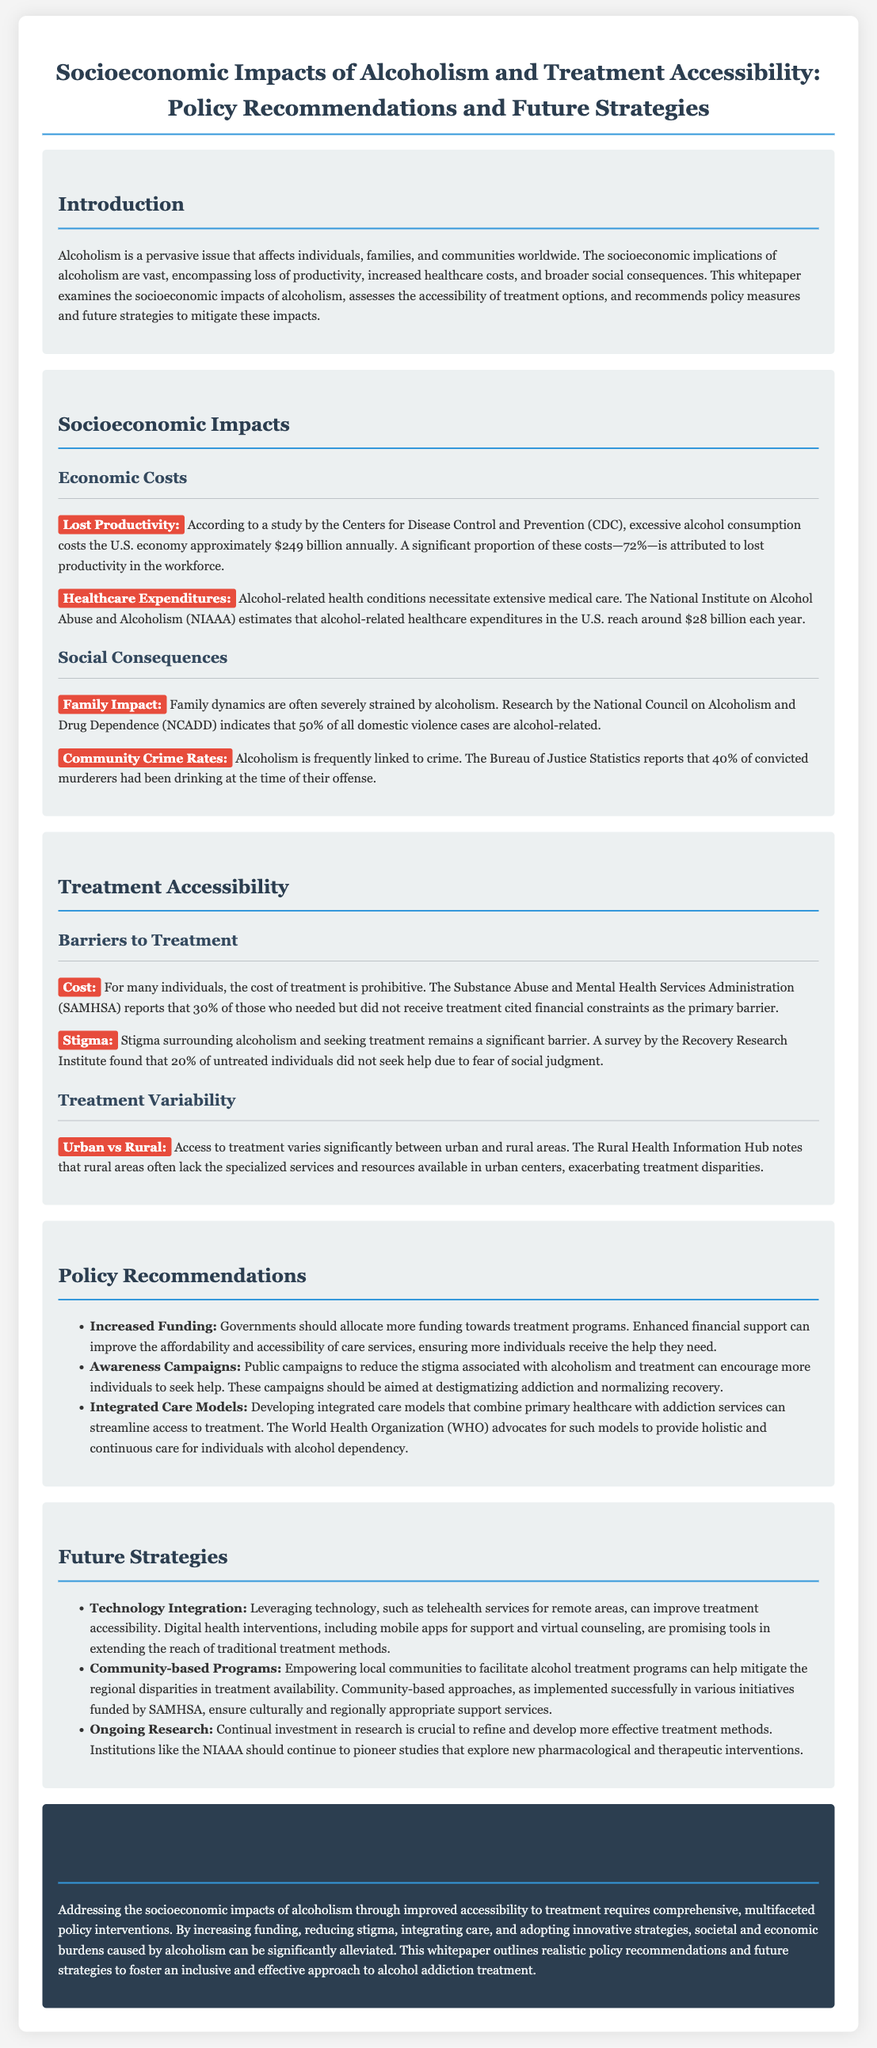What is the annual economic cost of excessive alcohol consumption in the U.S.? The document states that excessive alcohol consumption costs the U.S. economy approximately $249 billion annually.
Answer: $249 billion What percentage of the economic costs is attributed to lost productivity? According to the document, 72% of these costs is attributed to lost productivity in the workforce.
Answer: 72% What is one major barrier to treatment cited by individuals who did not receive help? The document mentions that 30% of those who needed but did not receive treatment cited financial constraints as the primary barrier.
Answer: Financial constraints What role does stigma play in treatment accessibility? The document highlights that stigma surrounding alcoholism is a significant barrier, with 20% of untreated individuals not seeking help due to fear of social judgment.
Answer: Fear of social judgment Which organization advocates for integrated care models for alcohol dependency? The document states that the World Health Organization (WHO) advocates for integrated care models to combine primary healthcare with addiction services.
Answer: World Health Organization How does access to treatment differ between urban and rural areas? The document notes that rural areas often lack the specialized services and resources available in urban centers, exacerbating treatment disparities.
Answer: Treatment disparities What is one future strategy for improving treatment accessibility mentioned in the document? The document suggests leveraging technology, such as telehealth services for remote areas, as a strategy to improve treatment accessibility.
Answer: Telehealth services What percentage of domestic violence cases are alcohol-related? According to the document, research indicates that 50% of all domestic violence cases are alcohol-related.
Answer: 50% What is the aim of public awareness campaigns regarding alcoholism? The document states that public campaigns aim to reduce the stigma associated with alcoholism and treatment, encouraging more individuals to seek help.
Answer: Reduce stigma 